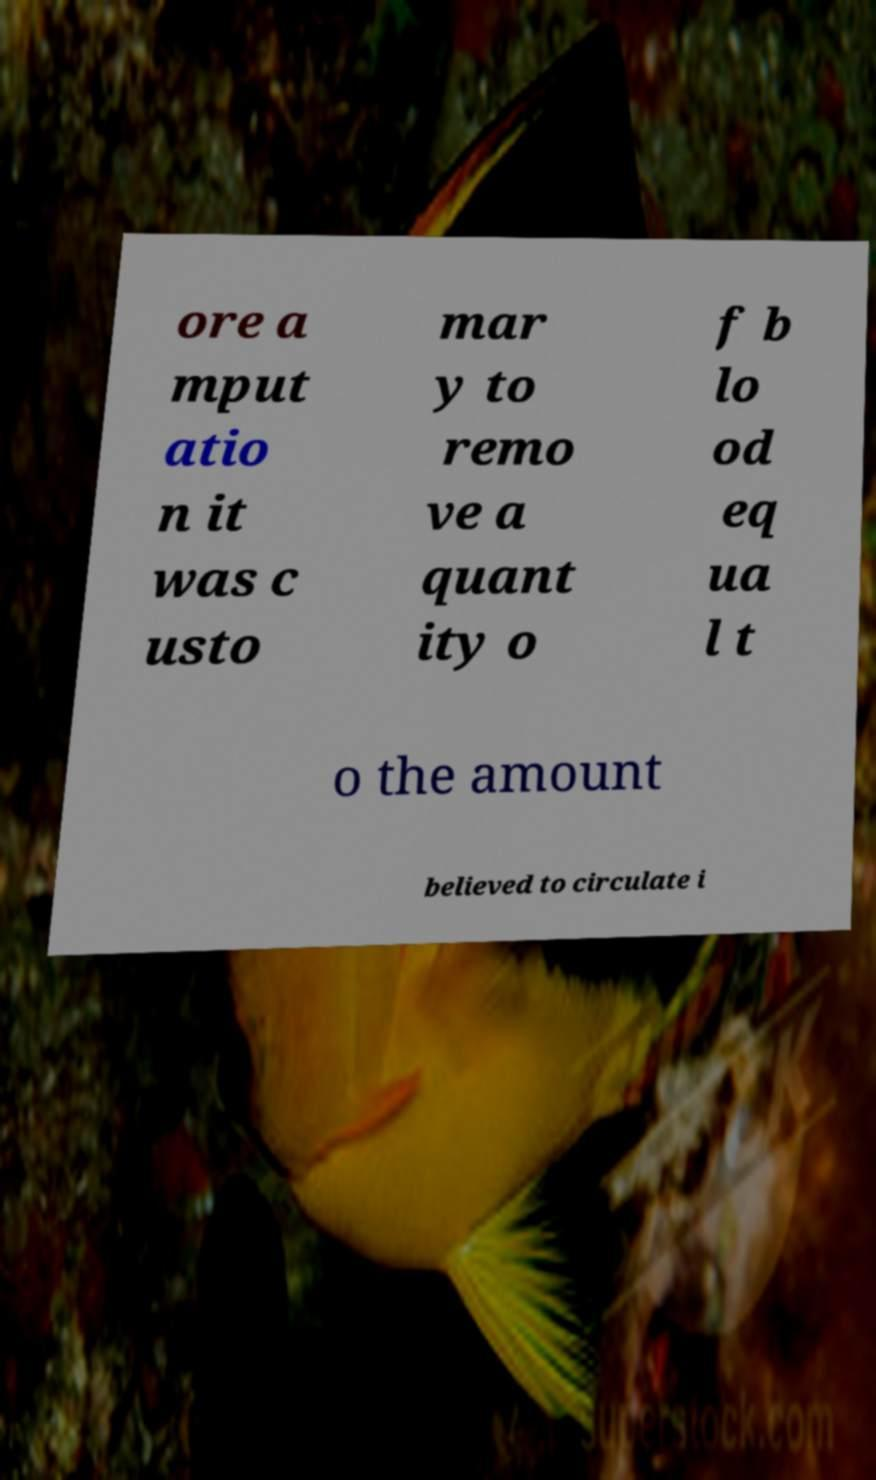For documentation purposes, I need the text within this image transcribed. Could you provide that? ore a mput atio n it was c usto mar y to remo ve a quant ity o f b lo od eq ua l t o the amount believed to circulate i 